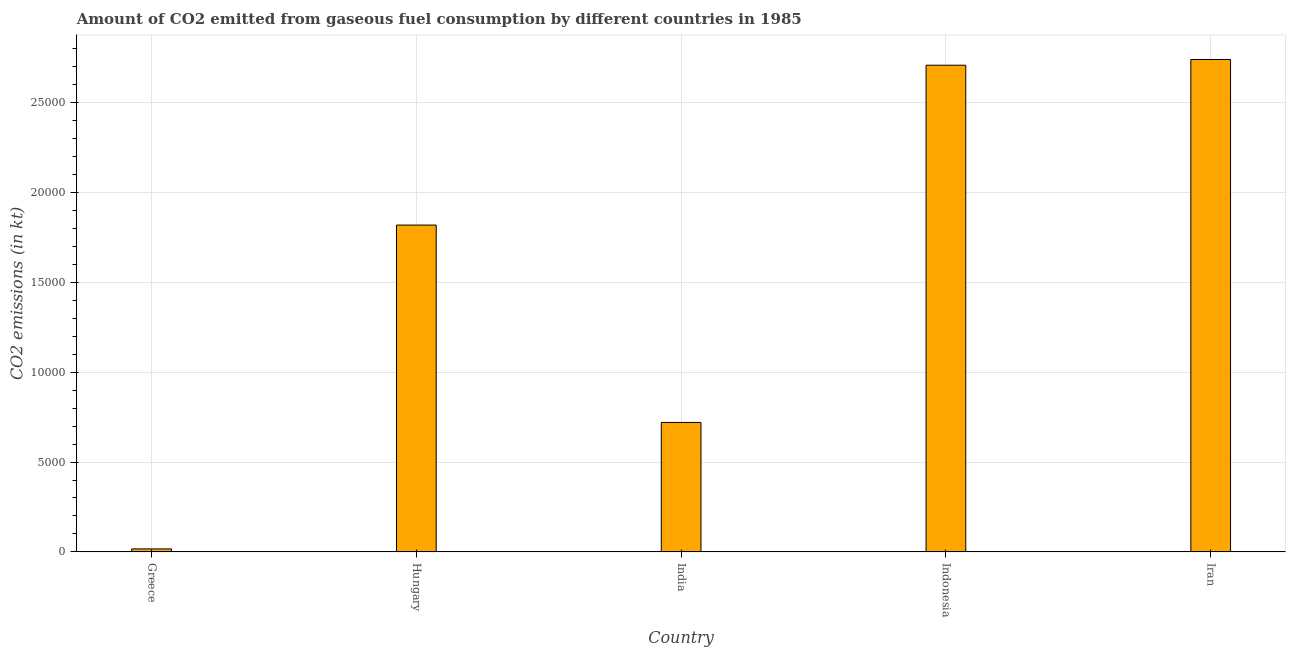Does the graph contain any zero values?
Your answer should be very brief. No. Does the graph contain grids?
Keep it short and to the point. Yes. What is the title of the graph?
Your answer should be very brief. Amount of CO2 emitted from gaseous fuel consumption by different countries in 1985. What is the label or title of the Y-axis?
Your answer should be very brief. CO2 emissions (in kt). What is the co2 emissions from gaseous fuel consumption in Indonesia?
Give a very brief answer. 2.71e+04. Across all countries, what is the maximum co2 emissions from gaseous fuel consumption?
Keep it short and to the point. 2.74e+04. Across all countries, what is the minimum co2 emissions from gaseous fuel consumption?
Give a very brief answer. 165.01. In which country was the co2 emissions from gaseous fuel consumption maximum?
Your answer should be very brief. Iran. What is the sum of the co2 emissions from gaseous fuel consumption?
Make the answer very short. 8.01e+04. What is the difference between the co2 emissions from gaseous fuel consumption in India and Iran?
Offer a very short reply. -2.02e+04. What is the average co2 emissions from gaseous fuel consumption per country?
Provide a short and direct response. 1.60e+04. What is the median co2 emissions from gaseous fuel consumption?
Ensure brevity in your answer.  1.82e+04. In how many countries, is the co2 emissions from gaseous fuel consumption greater than 2000 kt?
Your answer should be compact. 4. What is the ratio of the co2 emissions from gaseous fuel consumption in Greece to that in Indonesia?
Your response must be concise. 0.01. Is the co2 emissions from gaseous fuel consumption in Hungary less than that in India?
Give a very brief answer. No. What is the difference between the highest and the second highest co2 emissions from gaseous fuel consumption?
Your response must be concise. 319.03. Is the sum of the co2 emissions from gaseous fuel consumption in Hungary and Iran greater than the maximum co2 emissions from gaseous fuel consumption across all countries?
Your answer should be compact. Yes. What is the difference between the highest and the lowest co2 emissions from gaseous fuel consumption?
Your answer should be compact. 2.72e+04. In how many countries, is the co2 emissions from gaseous fuel consumption greater than the average co2 emissions from gaseous fuel consumption taken over all countries?
Your answer should be very brief. 3. Are all the bars in the graph horizontal?
Your answer should be compact. No. What is the difference between two consecutive major ticks on the Y-axis?
Provide a succinct answer. 5000. What is the CO2 emissions (in kt) in Greece?
Your response must be concise. 165.01. What is the CO2 emissions (in kt) of Hungary?
Provide a short and direct response. 1.82e+04. What is the CO2 emissions (in kt) of India?
Your response must be concise. 7205.65. What is the CO2 emissions (in kt) of Indonesia?
Provide a succinct answer. 2.71e+04. What is the CO2 emissions (in kt) of Iran?
Keep it short and to the point. 2.74e+04. What is the difference between the CO2 emissions (in kt) in Greece and Hungary?
Ensure brevity in your answer.  -1.80e+04. What is the difference between the CO2 emissions (in kt) in Greece and India?
Keep it short and to the point. -7040.64. What is the difference between the CO2 emissions (in kt) in Greece and Indonesia?
Offer a very short reply. -2.69e+04. What is the difference between the CO2 emissions (in kt) in Greece and Iran?
Your response must be concise. -2.72e+04. What is the difference between the CO2 emissions (in kt) in Hungary and India?
Your answer should be compact. 1.10e+04. What is the difference between the CO2 emissions (in kt) in Hungary and Indonesia?
Give a very brief answer. -8899.81. What is the difference between the CO2 emissions (in kt) in Hungary and Iran?
Offer a terse response. -9218.84. What is the difference between the CO2 emissions (in kt) in India and Indonesia?
Offer a very short reply. -1.99e+04. What is the difference between the CO2 emissions (in kt) in India and Iran?
Keep it short and to the point. -2.02e+04. What is the difference between the CO2 emissions (in kt) in Indonesia and Iran?
Offer a terse response. -319.03. What is the ratio of the CO2 emissions (in kt) in Greece to that in Hungary?
Your answer should be very brief. 0.01. What is the ratio of the CO2 emissions (in kt) in Greece to that in India?
Provide a short and direct response. 0.02. What is the ratio of the CO2 emissions (in kt) in Greece to that in Indonesia?
Offer a terse response. 0.01. What is the ratio of the CO2 emissions (in kt) in Greece to that in Iran?
Offer a terse response. 0.01. What is the ratio of the CO2 emissions (in kt) in Hungary to that in India?
Make the answer very short. 2.52. What is the ratio of the CO2 emissions (in kt) in Hungary to that in Indonesia?
Ensure brevity in your answer.  0.67. What is the ratio of the CO2 emissions (in kt) in Hungary to that in Iran?
Your response must be concise. 0.66. What is the ratio of the CO2 emissions (in kt) in India to that in Indonesia?
Make the answer very short. 0.27. What is the ratio of the CO2 emissions (in kt) in India to that in Iran?
Provide a short and direct response. 0.26. 